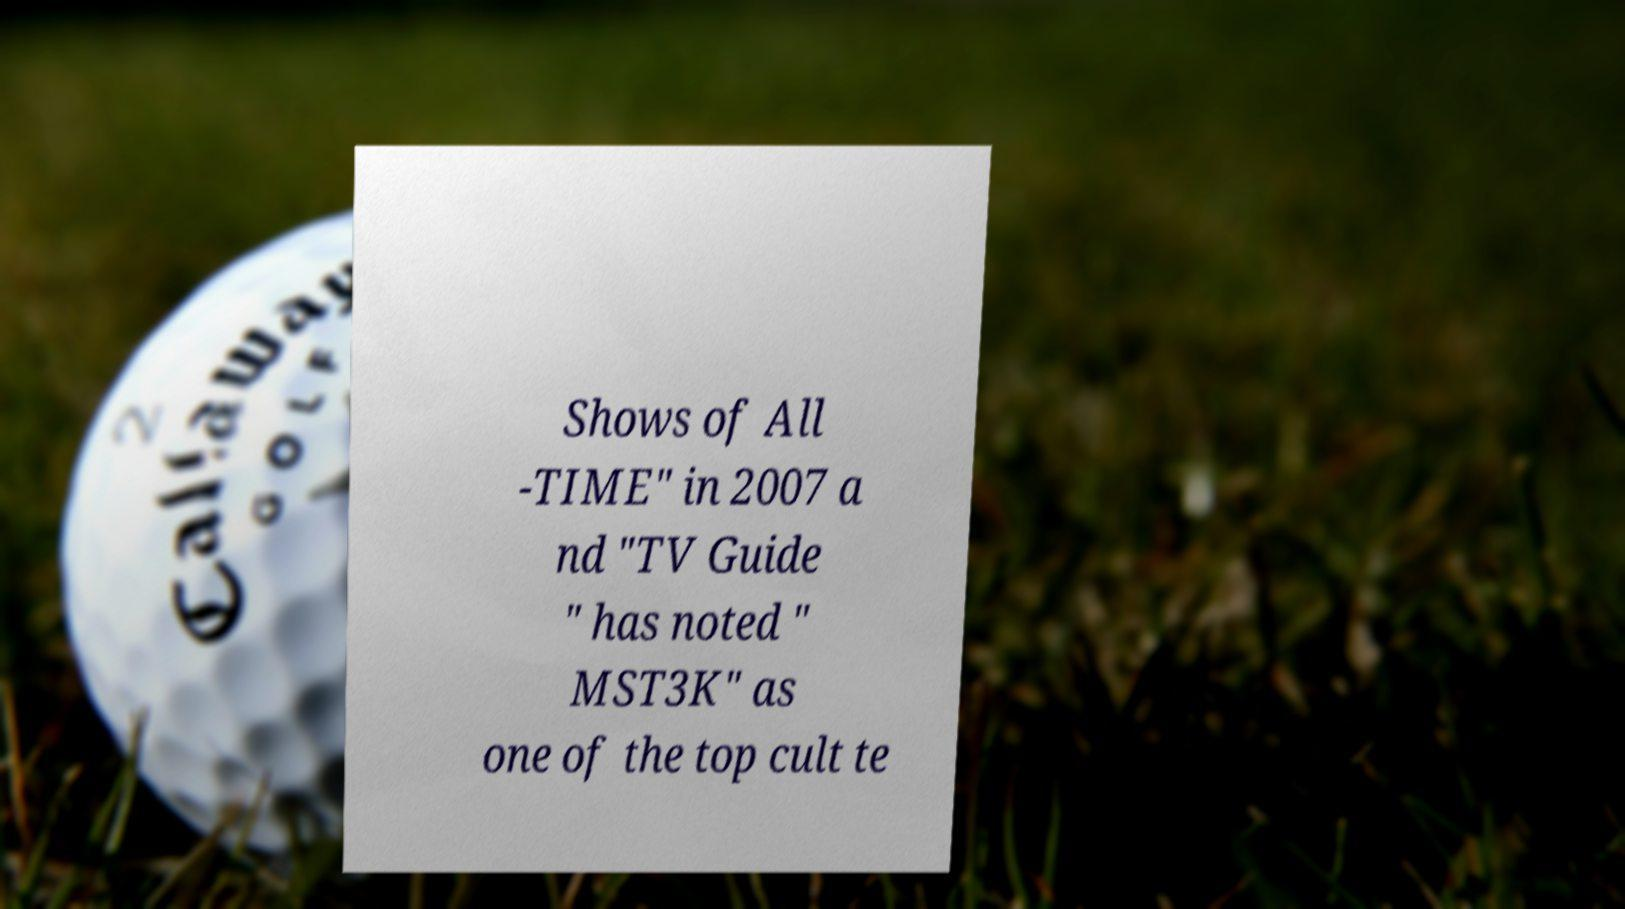Can you accurately transcribe the text from the provided image for me? Shows of All -TIME" in 2007 a nd "TV Guide " has noted " MST3K" as one of the top cult te 